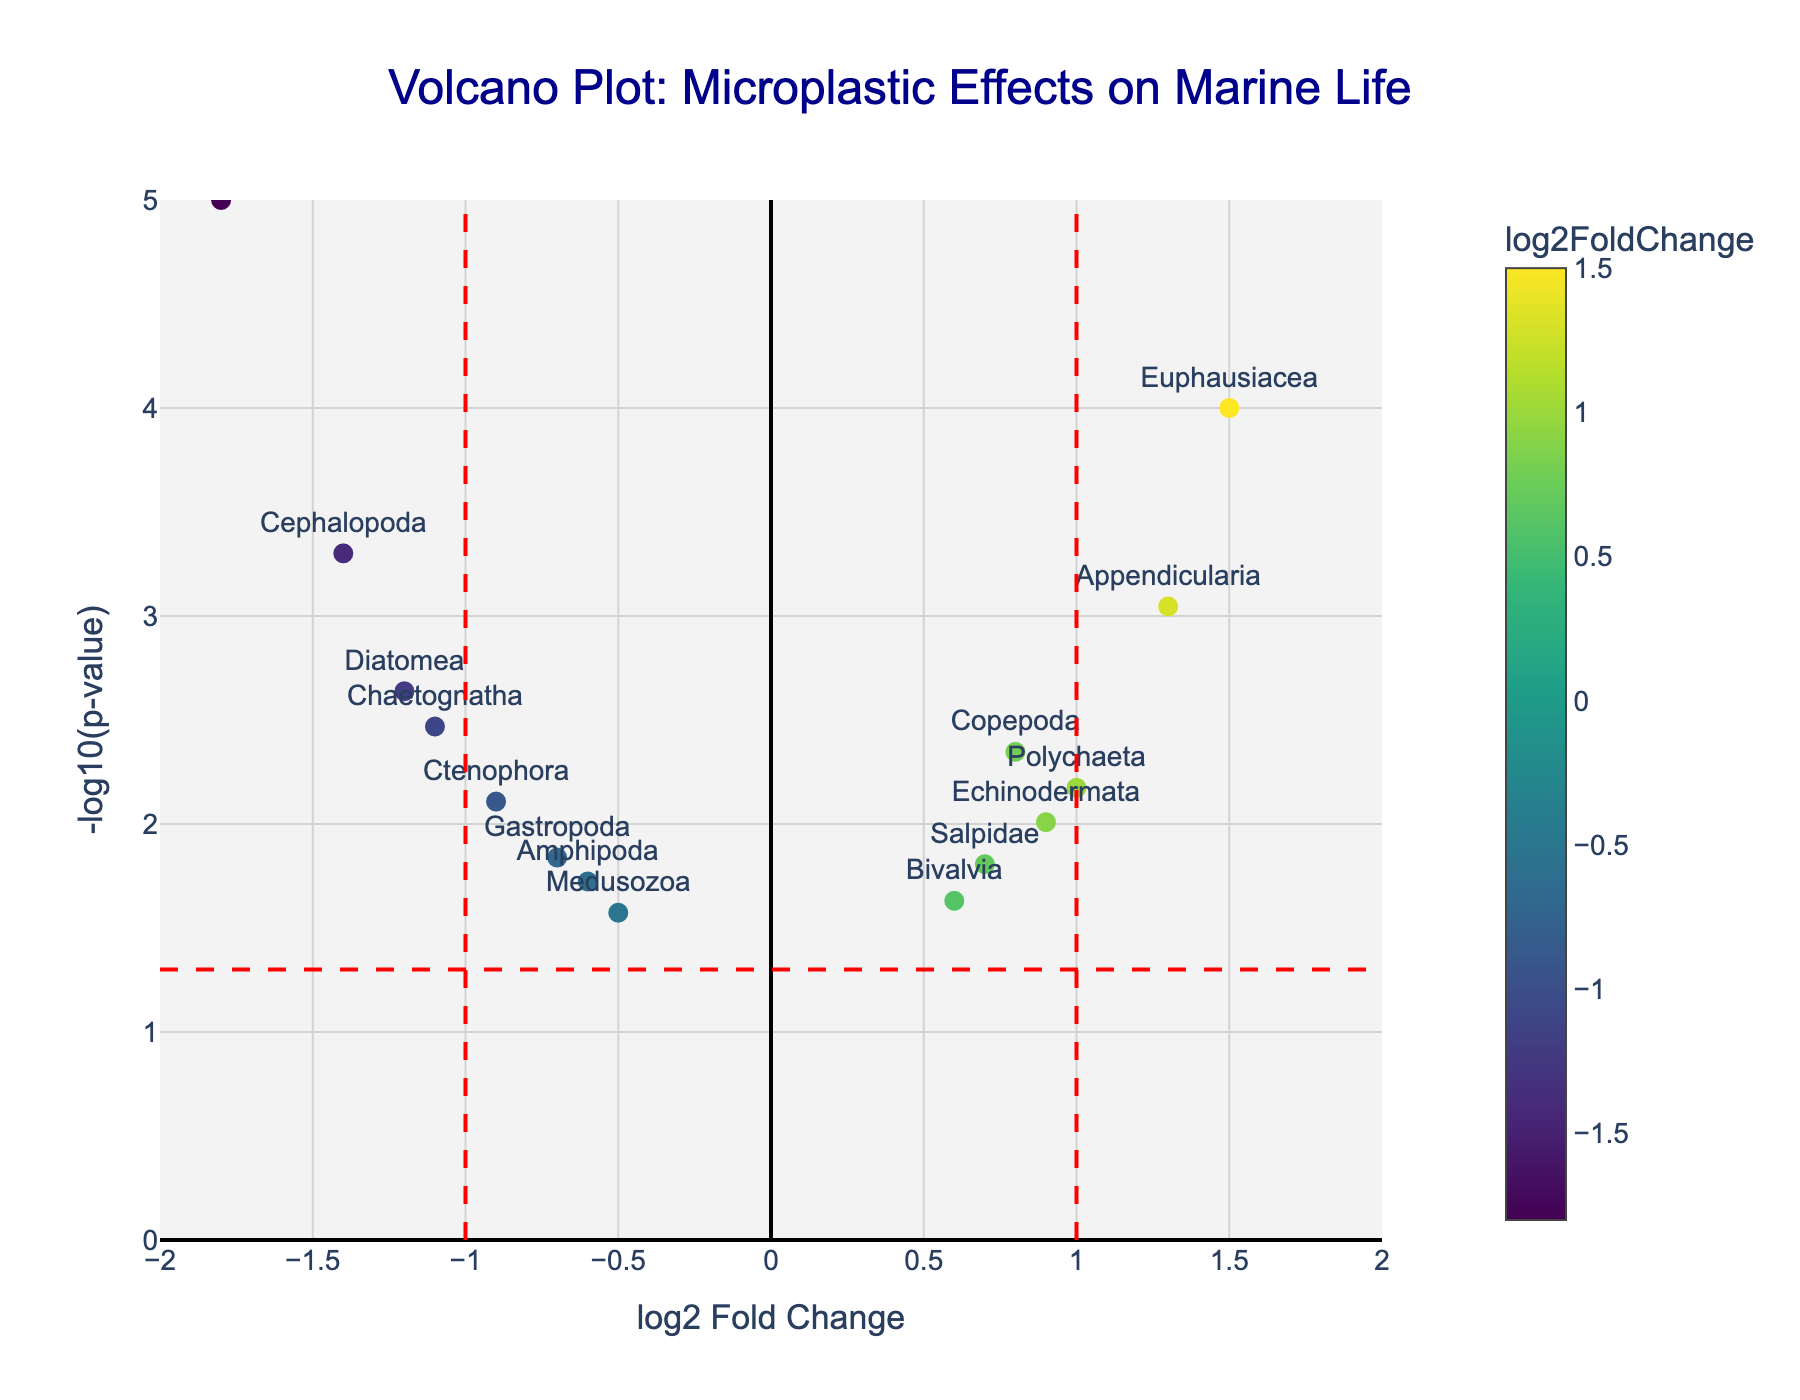Which ocean zone has the highest -log10(p-value) for a given species? Looking at the vertical position of data points, the highest -log10(p-value) corresponds to the species that is both higher up and more significant on the y-axis. Identify which species is highest.
Answer: Euphausiacea What is the log2 Fold Change value for the species "Pisces"? Locate the data point for Pisces on the x-axis. The horizontal position of Pisces determines its log2 Fold Change value.
Answer: -1.8 How many data points have a log2 Fold Change greater than 0 but a -log10(p-value) less than 1.5? Examine the plot for points in the right half (log2 Fold Change > 0) and below the horizontal y value of 1.5. Count these points.
Answer: 2 Which species has the smallest p-value? The smallest p-value corresponds to the highest -log10(p-value). Identify the species at the topmost point on the y-axis.
Answer: Pisces What is the median -log10(p-value) among all the species? Sort the data points by their -log10(p-value) values, then find the middle value. If there's an even number of points, average the two middle values. The intermediate steps involve calculating -log10(0.0234), -log10(0.0145), -log10(0.0189), etc., and then finding the central value.
Answer: Around 2.34 What is the range of log2 Fold Change values for species with p-values less than 0.05? Identify points above the horizontal line at -log10(0.05). Determine the smallest and largest x-values (log2 Fold Change) of these points. Subtract the smallest from the largest.
Answer: 3.3 (-1.8 to 1.5) Which species fall outside the thresholds defined by the dashed red vertical lines? Identify species with log2 Fold Change less than -1 or greater than 1 as they are outside the dashed red vertical lines. List these species.
Answer: Diatomea, Chaetognatha, Cephalopoda, Pisces, Euphausiacea, Appendicularia 